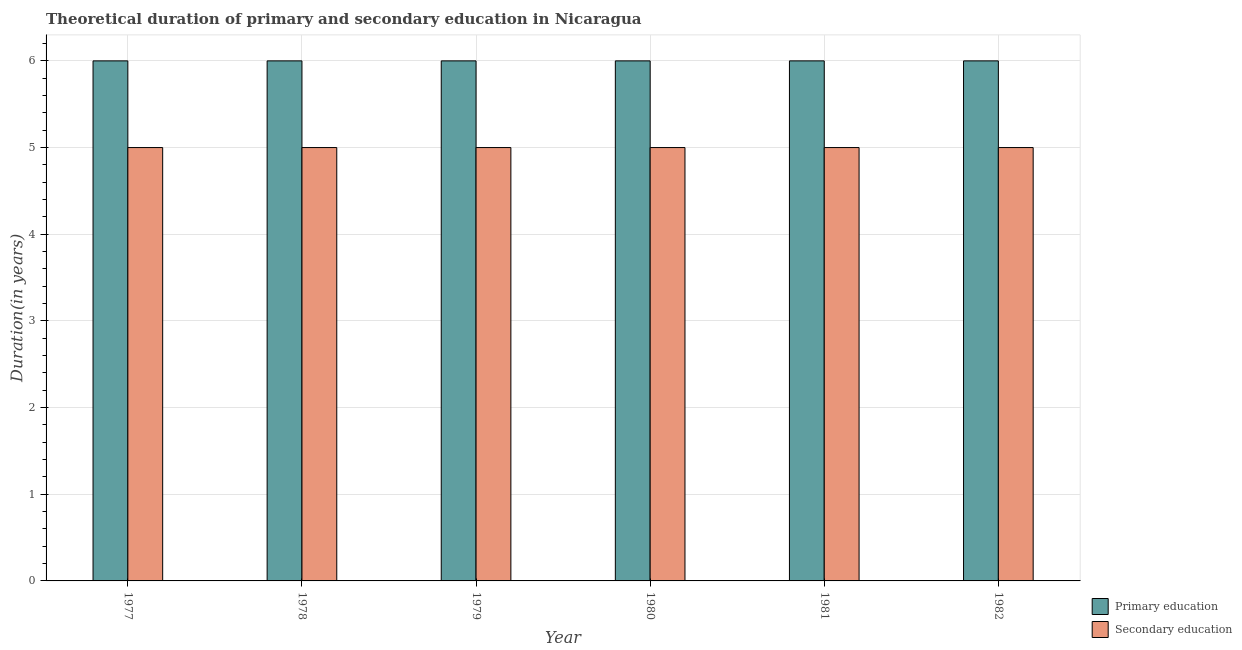How many groups of bars are there?
Provide a short and direct response. 6. Are the number of bars on each tick of the X-axis equal?
Provide a short and direct response. Yes. How many bars are there on the 2nd tick from the right?
Your response must be concise. 2. What is the label of the 5th group of bars from the left?
Provide a short and direct response. 1981. In how many cases, is the number of bars for a given year not equal to the number of legend labels?
Make the answer very short. 0. What is the duration of secondary education in 1979?
Your response must be concise. 5. Across all years, what is the minimum duration of secondary education?
Your response must be concise. 5. What is the total duration of secondary education in the graph?
Your answer should be compact. 30. What is the average duration of primary education per year?
Your response must be concise. 6. Is the difference between the duration of primary education in 1978 and 1982 greater than the difference between the duration of secondary education in 1978 and 1982?
Give a very brief answer. No. What is the difference between the highest and the second highest duration of primary education?
Your answer should be very brief. 0. What is the difference between the highest and the lowest duration of secondary education?
Offer a terse response. 0. In how many years, is the duration of secondary education greater than the average duration of secondary education taken over all years?
Make the answer very short. 0. What does the 1st bar from the left in 1982 represents?
Your response must be concise. Primary education. How many bars are there?
Keep it short and to the point. 12. Are all the bars in the graph horizontal?
Give a very brief answer. No. What is the difference between two consecutive major ticks on the Y-axis?
Your answer should be very brief. 1. Are the values on the major ticks of Y-axis written in scientific E-notation?
Your answer should be very brief. No. Does the graph contain any zero values?
Provide a short and direct response. No. Does the graph contain grids?
Provide a succinct answer. Yes. What is the title of the graph?
Ensure brevity in your answer.  Theoretical duration of primary and secondary education in Nicaragua. Does "Frequency of shipment arrival" appear as one of the legend labels in the graph?
Provide a short and direct response. No. What is the label or title of the X-axis?
Your answer should be very brief. Year. What is the label or title of the Y-axis?
Give a very brief answer. Duration(in years). What is the Duration(in years) in Primary education in 1981?
Offer a very short reply. 6. What is the Duration(in years) of Secondary education in 1981?
Make the answer very short. 5. What is the Duration(in years) of Primary education in 1982?
Offer a terse response. 6. Across all years, what is the maximum Duration(in years) of Secondary education?
Keep it short and to the point. 5. Across all years, what is the minimum Duration(in years) in Primary education?
Make the answer very short. 6. Across all years, what is the minimum Duration(in years) of Secondary education?
Offer a terse response. 5. What is the total Duration(in years) in Primary education in the graph?
Keep it short and to the point. 36. What is the total Duration(in years) of Secondary education in the graph?
Make the answer very short. 30. What is the difference between the Duration(in years) of Primary education in 1977 and that in 1978?
Provide a succinct answer. 0. What is the difference between the Duration(in years) in Primary education in 1977 and that in 1979?
Your response must be concise. 0. What is the difference between the Duration(in years) of Secondary education in 1977 and that in 1979?
Make the answer very short. 0. What is the difference between the Duration(in years) in Primary education in 1977 and that in 1980?
Ensure brevity in your answer.  0. What is the difference between the Duration(in years) in Primary education in 1977 and that in 1981?
Offer a terse response. 0. What is the difference between the Duration(in years) of Secondary education in 1977 and that in 1982?
Ensure brevity in your answer.  0. What is the difference between the Duration(in years) of Secondary education in 1978 and that in 1980?
Offer a terse response. 0. What is the difference between the Duration(in years) of Primary education in 1978 and that in 1981?
Ensure brevity in your answer.  0. What is the difference between the Duration(in years) in Secondary education in 1978 and that in 1981?
Your response must be concise. 0. What is the difference between the Duration(in years) in Primary education in 1979 and that in 1980?
Make the answer very short. 0. What is the difference between the Duration(in years) of Secondary education in 1979 and that in 1980?
Ensure brevity in your answer.  0. What is the difference between the Duration(in years) in Secondary education in 1979 and that in 1981?
Provide a short and direct response. 0. What is the difference between the Duration(in years) in Primary education in 1979 and that in 1982?
Your answer should be very brief. 0. What is the difference between the Duration(in years) of Primary education in 1980 and that in 1981?
Your answer should be very brief. 0. What is the difference between the Duration(in years) in Secondary education in 1980 and that in 1982?
Offer a terse response. 0. What is the difference between the Duration(in years) of Primary education in 1981 and that in 1982?
Provide a succinct answer. 0. What is the difference between the Duration(in years) of Secondary education in 1981 and that in 1982?
Your answer should be very brief. 0. What is the difference between the Duration(in years) in Primary education in 1977 and the Duration(in years) in Secondary education in 1978?
Give a very brief answer. 1. What is the difference between the Duration(in years) in Primary education in 1977 and the Duration(in years) in Secondary education in 1981?
Offer a very short reply. 1. What is the difference between the Duration(in years) in Primary education in 1978 and the Duration(in years) in Secondary education in 1980?
Provide a succinct answer. 1. What is the difference between the Duration(in years) in Primary education in 1978 and the Duration(in years) in Secondary education in 1981?
Your answer should be very brief. 1. What is the difference between the Duration(in years) in Primary education in 1979 and the Duration(in years) in Secondary education in 1980?
Offer a very short reply. 1. What is the difference between the Duration(in years) of Primary education in 1980 and the Duration(in years) of Secondary education in 1981?
Ensure brevity in your answer.  1. What is the difference between the Duration(in years) in Primary education in 1980 and the Duration(in years) in Secondary education in 1982?
Keep it short and to the point. 1. What is the average Duration(in years) in Primary education per year?
Provide a succinct answer. 6. In the year 1977, what is the difference between the Duration(in years) of Primary education and Duration(in years) of Secondary education?
Provide a succinct answer. 1. In the year 1980, what is the difference between the Duration(in years) of Primary education and Duration(in years) of Secondary education?
Offer a very short reply. 1. What is the ratio of the Duration(in years) of Primary education in 1977 to that in 1978?
Your answer should be compact. 1. What is the ratio of the Duration(in years) of Secondary education in 1977 to that in 1978?
Give a very brief answer. 1. What is the ratio of the Duration(in years) in Secondary education in 1977 to that in 1979?
Your answer should be very brief. 1. What is the ratio of the Duration(in years) of Primary education in 1977 to that in 1980?
Provide a short and direct response. 1. What is the ratio of the Duration(in years) in Secondary education in 1977 to that in 1981?
Give a very brief answer. 1. What is the ratio of the Duration(in years) in Primary education in 1977 to that in 1982?
Offer a terse response. 1. What is the ratio of the Duration(in years) of Primary education in 1978 to that in 1979?
Provide a short and direct response. 1. What is the ratio of the Duration(in years) in Primary education in 1978 to that in 1980?
Your answer should be very brief. 1. What is the ratio of the Duration(in years) in Secondary education in 1978 to that in 1980?
Ensure brevity in your answer.  1. What is the ratio of the Duration(in years) in Secondary education in 1978 to that in 1981?
Provide a short and direct response. 1. What is the ratio of the Duration(in years) in Primary education in 1978 to that in 1982?
Ensure brevity in your answer.  1. What is the ratio of the Duration(in years) in Primary education in 1979 to that in 1980?
Your answer should be very brief. 1. What is the ratio of the Duration(in years) in Secondary education in 1979 to that in 1980?
Ensure brevity in your answer.  1. What is the ratio of the Duration(in years) in Secondary education in 1979 to that in 1981?
Make the answer very short. 1. What is the ratio of the Duration(in years) in Primary education in 1979 to that in 1982?
Give a very brief answer. 1. What is the ratio of the Duration(in years) of Secondary education in 1979 to that in 1982?
Ensure brevity in your answer.  1. What is the ratio of the Duration(in years) in Primary education in 1980 to that in 1981?
Offer a very short reply. 1. What is the ratio of the Duration(in years) of Primary education in 1980 to that in 1982?
Your answer should be compact. 1. What is the ratio of the Duration(in years) in Secondary education in 1980 to that in 1982?
Provide a succinct answer. 1. What is the difference between the highest and the second highest Duration(in years) of Secondary education?
Your answer should be compact. 0. What is the difference between the highest and the lowest Duration(in years) of Primary education?
Make the answer very short. 0. 